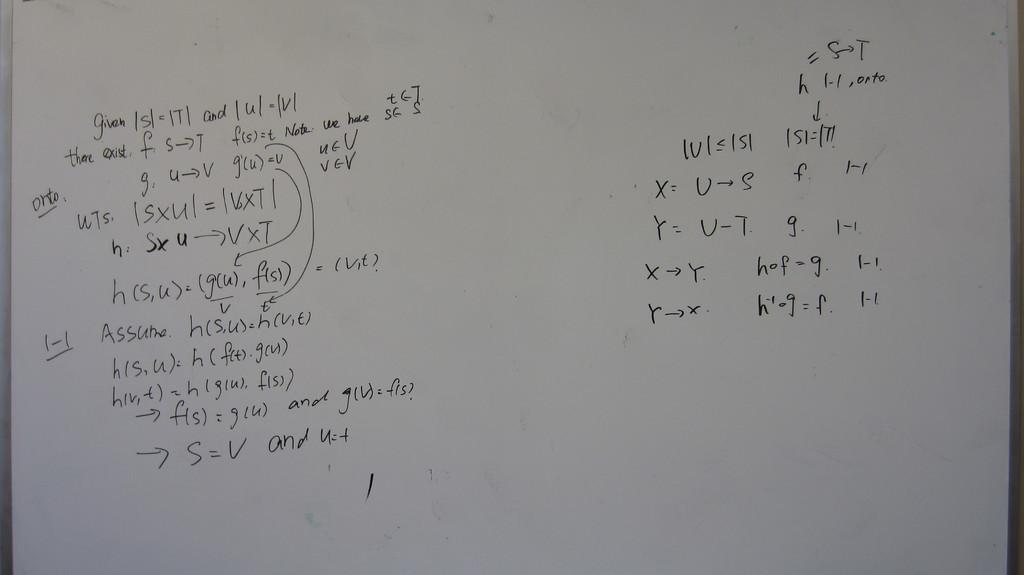<image>
Create a compact narrative representing the image presented. White board which has an equation with the letters x and y 